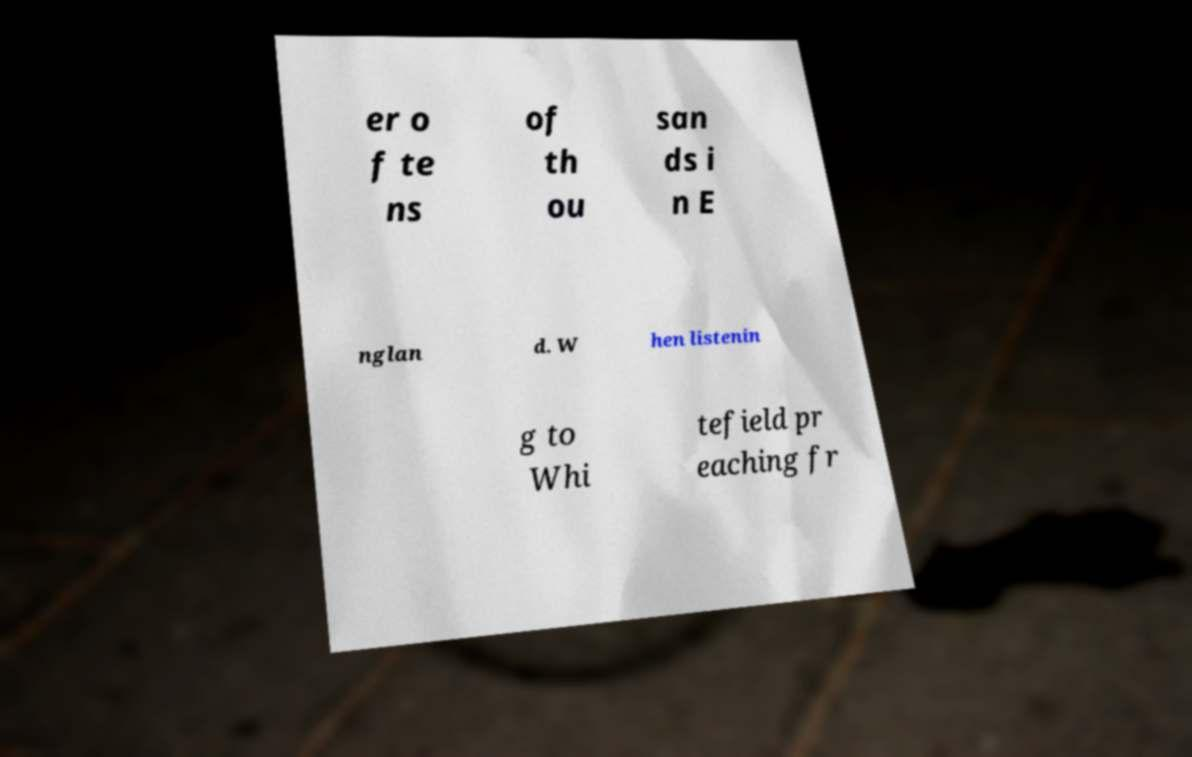Could you extract and type out the text from this image? er o f te ns of th ou san ds i n E nglan d. W hen listenin g to Whi tefield pr eaching fr 